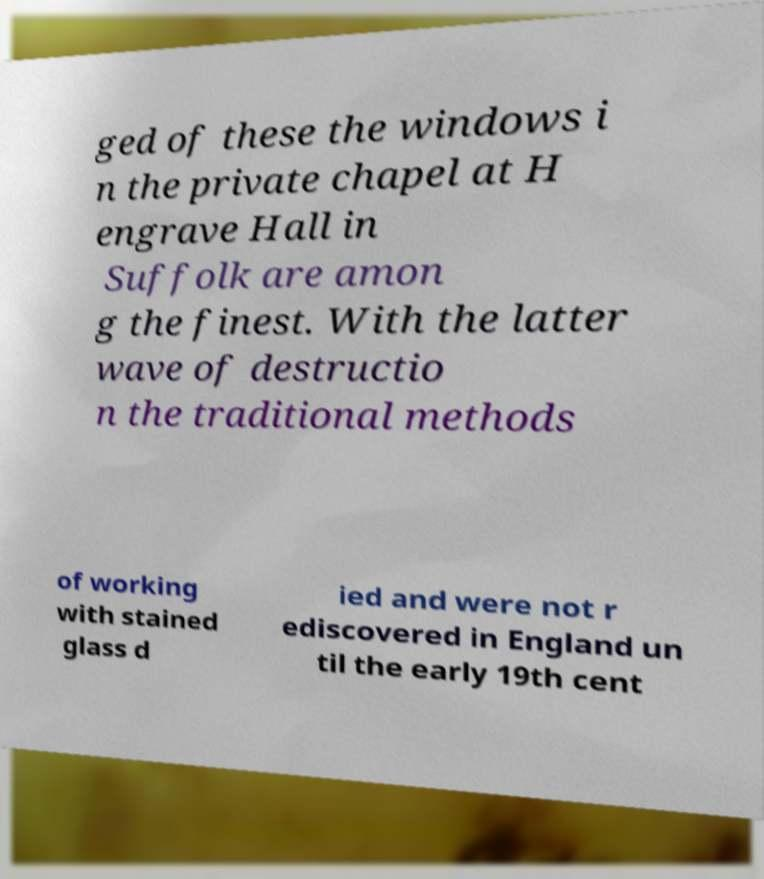There's text embedded in this image that I need extracted. Can you transcribe it verbatim? ged of these the windows i n the private chapel at H engrave Hall in Suffolk are amon g the finest. With the latter wave of destructio n the traditional methods of working with stained glass d ied and were not r ediscovered in England un til the early 19th cent 